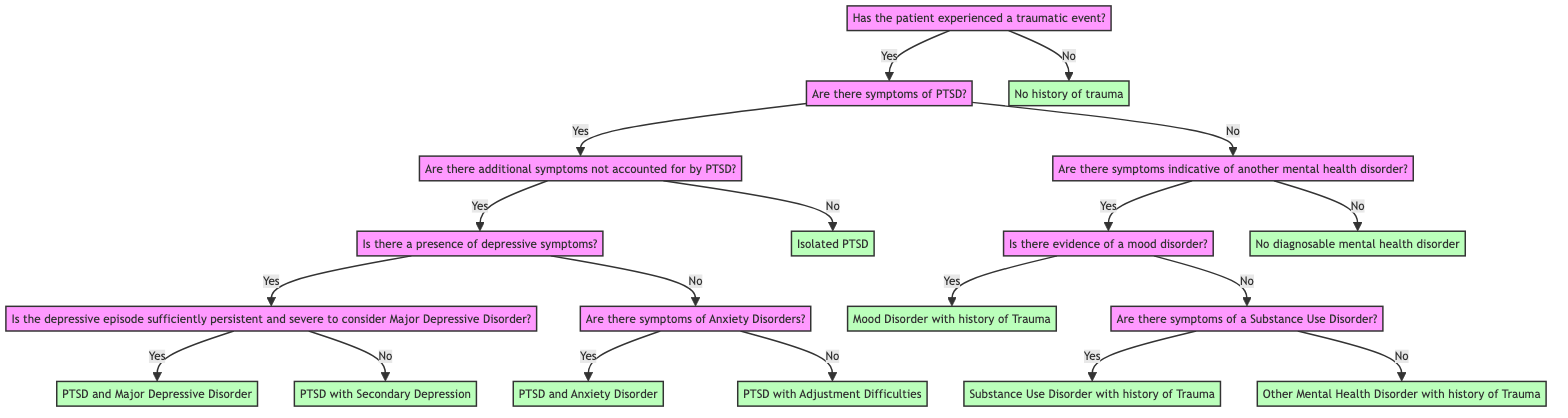Has the patient experienced a traumatic event? This is the root question of the diagram. It determines the initial path the decision tree will take based on whether the answer is "yes" or "no".
Answer: Yes What is the diagnosis if there are PTSD symptoms and additional depressive symptoms? Following "Yes" to the PTSD symptoms, if there are additional symptoms not accounted for by PTSD, and if the depressive episode is persistently severe, the diagnosis becomes "PTSD and Major Depressive Disorder".
Answer: PTSD and Major Depressive Disorder How many possible diagnoses can be reached if the patient has not experienced a traumatic event? If the root question is answered "No", the only diagnosis provided in this path is "No history of trauma", resulting in one possible diagnosis.
Answer: 1 What happens if a patient shows PTSD symptoms but none of the additional symptoms? If the patient shows PTSD symptoms but does not have additional symptoms accounted for by PTSD, the result is "Isolated PTSD".
Answer: Isolated PTSD What diagnosis is assigned if there are symptoms of a mood disorder after identifying no PTSD symptoms? When the initial question of traumatic experience is "No" and the patient shows symptoms of another mental health disorder, if the symptoms indicate a mood disorder, the diagnosis is "Mood Disorder with history of Trauma".
Answer: Mood Disorder with history of Trauma What is the path if the patient has experienced a traumatic event but no PTSD symptoms? After the initial "Yes" for trauma, if the patient answers "No" to PTSD symptoms, the next step is to evaluate for other mental health disorders; then if symptoms indicative of another mental health disorder are present, it could lead to various diagnoses based on subsequent questions.
Answer: Various paths to diagnosis What is the final conclusion drawn if all evaluated symptoms indicated "no"? If all questions are answered "no" after experiencing a traumatic event and assessing other symptoms, the final conclusion is "No diagnosable mental health disorder".
Answer: No diagnosable mental health disorder What is the diagnosis if there is evidence of a Substance Use Disorder? If the patient indicates symptoms of another mental health disorder and specifically shows signs of a Substance Use Disorder, the conclusion drawn is "Substance Use Disorder with history of Trauma".
Answer: Substance Use Disorder with history of Trauma What is the relationship between PTSD and anxiety disorders in the diagnosis flow? The flow from PTSD symptoms goes to an evaluation of other symptoms; if anxiety disorders are identified, the diagnosis of "PTSD and Anxiety Disorder" is made, showing a specific co-occurrence relationship.
Answer: PTSD and Anxiety Disorder 